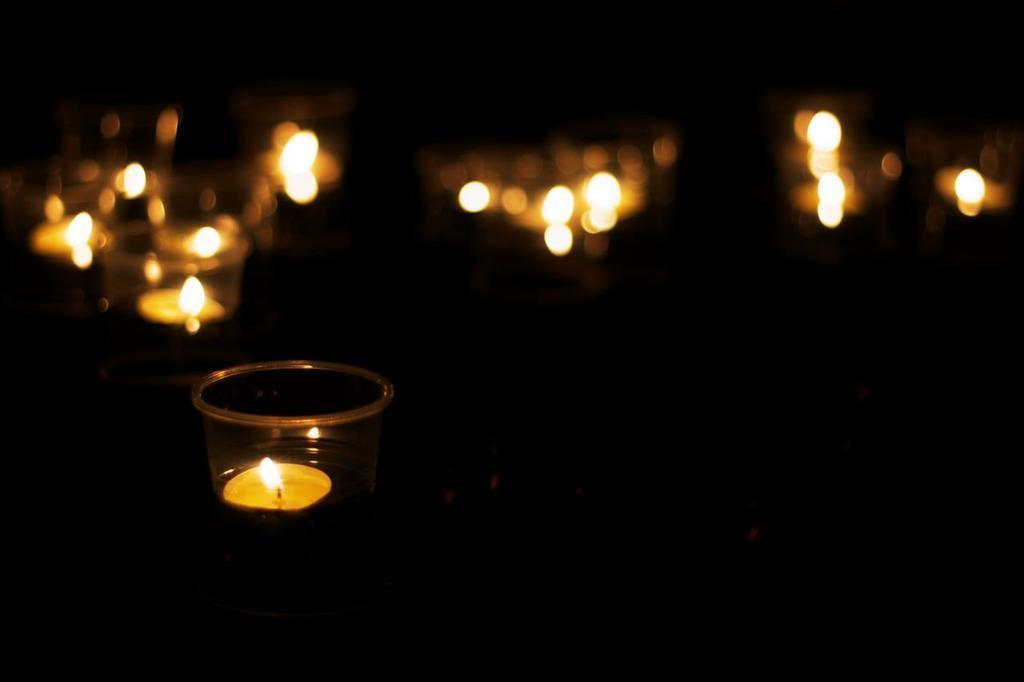Could you give a brief overview of what you see in this image? This is an image clicked in the dark. Here I can see few candles are placed in the bowls. The background is blurred. 